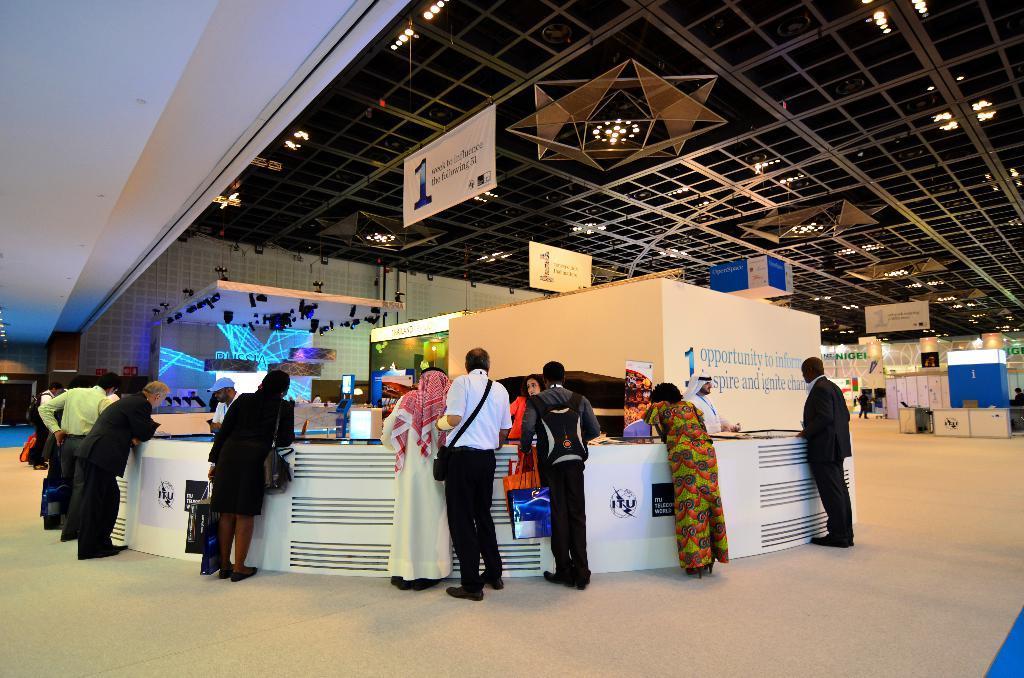Describe this image in one or two sentences. In this picture we can see a group of people standing on the floor, some people are carrying bags, banners, screens, lights, roof, walls and some objects. 